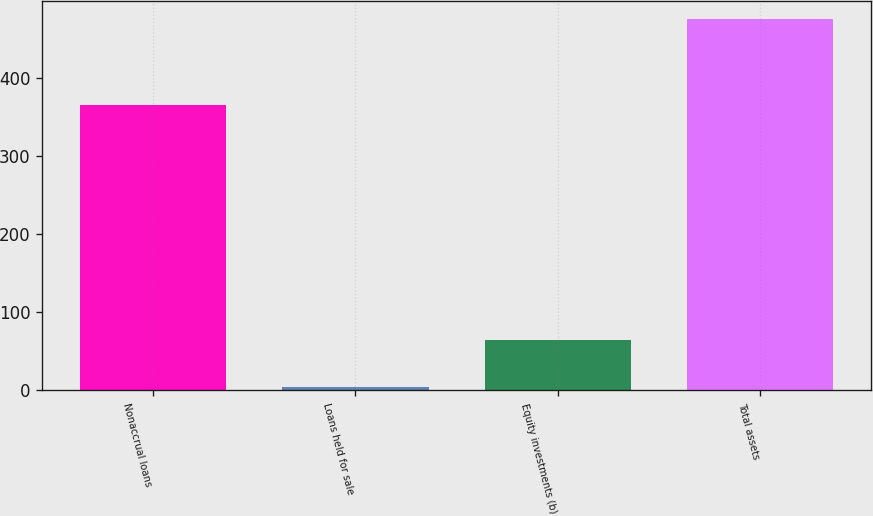<chart> <loc_0><loc_0><loc_500><loc_500><bar_chart><fcel>Nonaccrual loans<fcel>Loans held for sale<fcel>Equity investments (b)<fcel>Total assets<nl><fcel>365<fcel>4<fcel>64<fcel>475<nl></chart> 